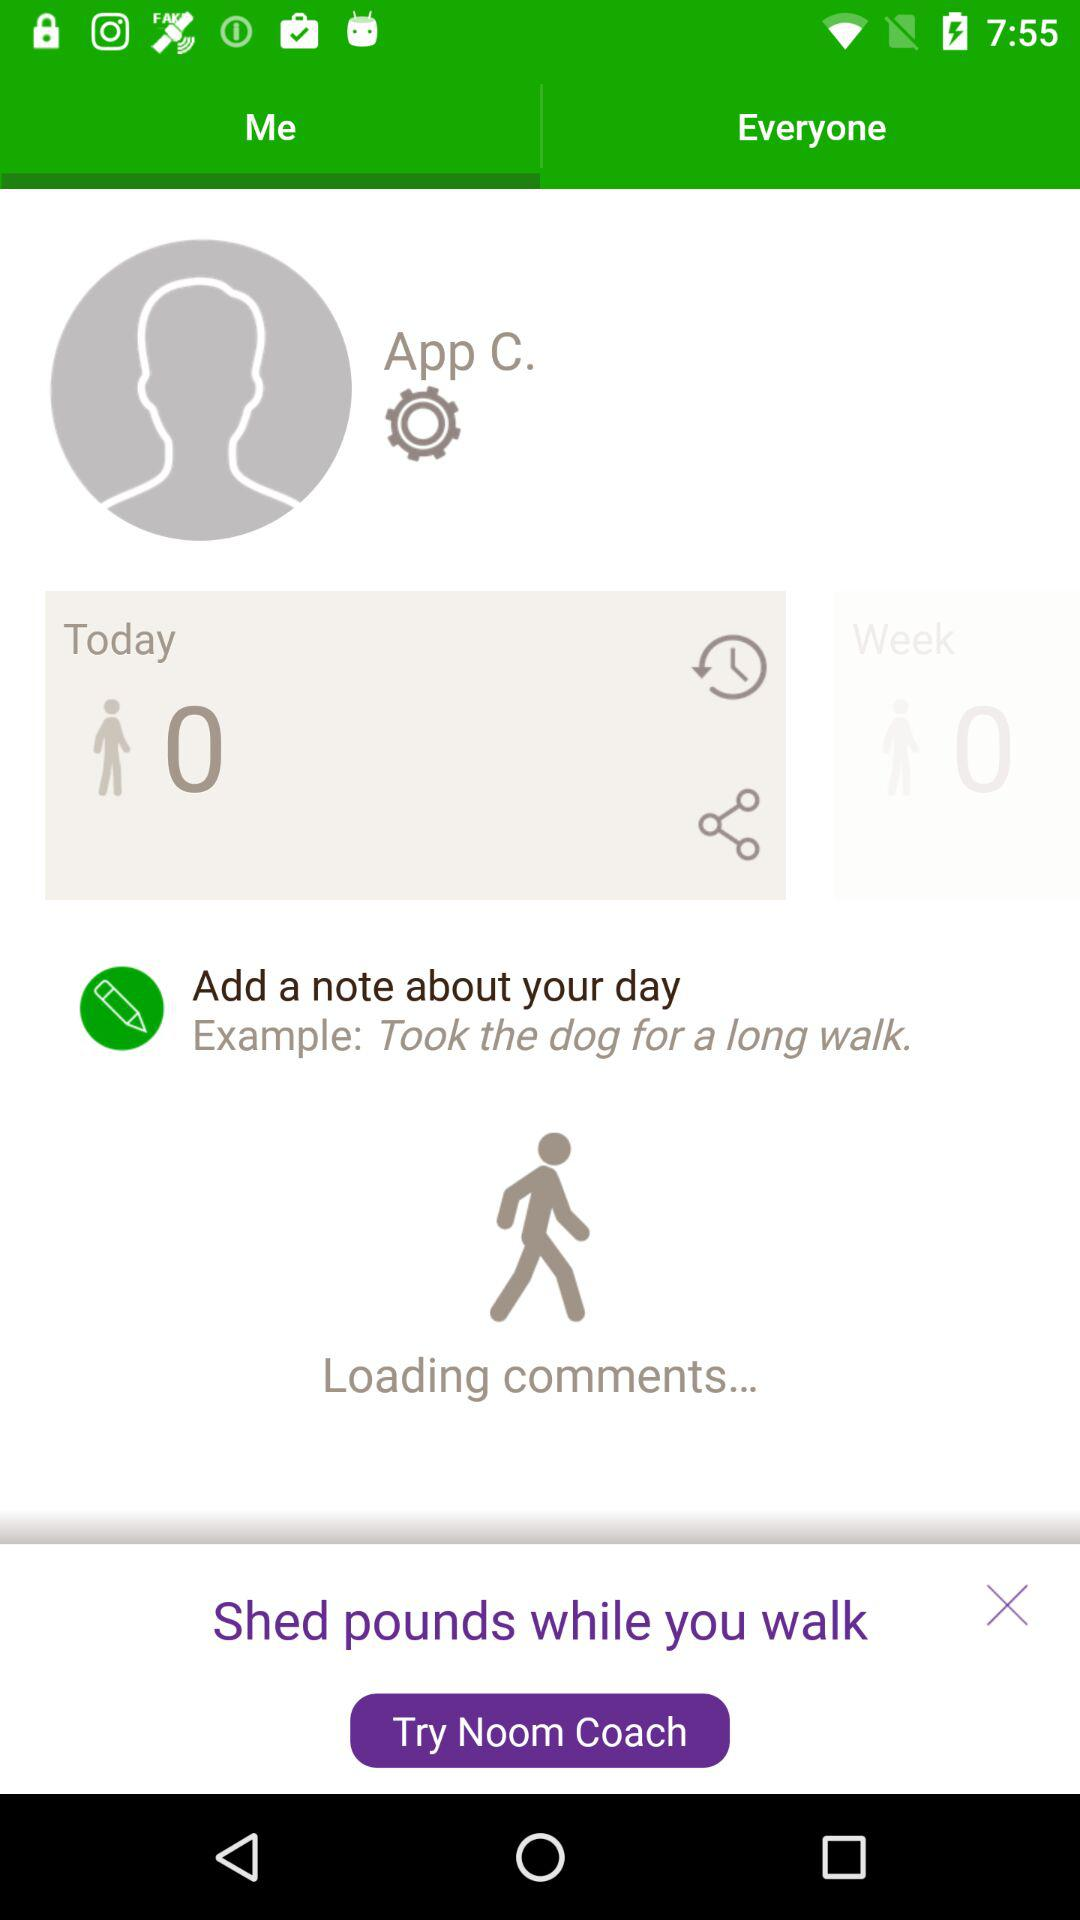What are the steps for today? The steps for today are zero. 